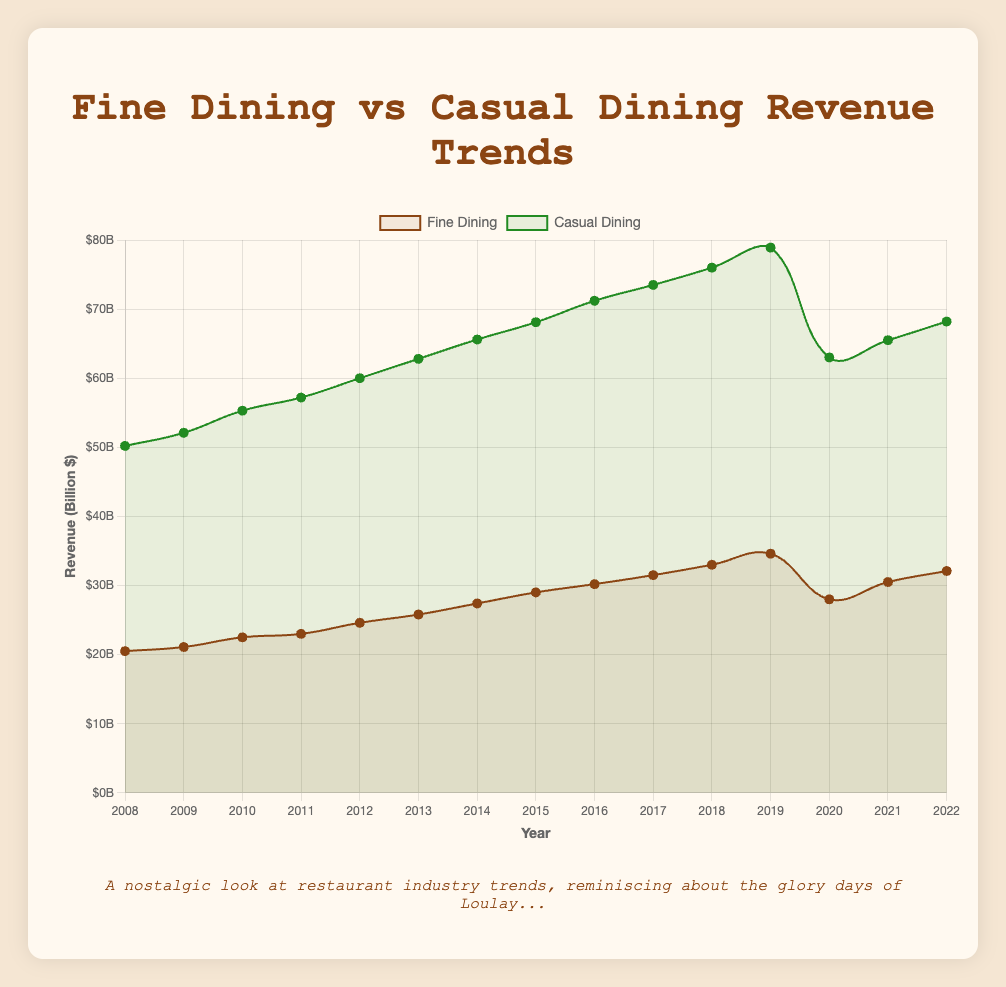What is the revenue difference between fine dining and casual dining in 2015? In 2015, fine dining revenue was $29.0 billion and casual dining revenue was $68.1 billion. The difference is $68.1 billion - $29.0 billion.
Answer: $39.1 billion Which year had the highest revenue for casual dining? By examining the plot, the highest point on the casual dining line corresponds to the year 2019.
Answer: 2019 In which year did fine dining revenue see the largest increase compared to the previous year? The largest increase in fine dining revenue occurred between 2012 and 2013, where the revenue increased from $24.6 billion to $25.8 billion.
Answer: 2013 What was the percentage drop in fine dining revenue from 2019 to 2020? Fine dining revenue dropped from $34.6 billion in 2019 to $28.0 billion in 2020. The percentage drop is calculated as ((34.6 - 28.0) / 34.6) * 100.
Answer: 19.1% Which type of dining experienced a steeper decline in revenue during 2020? Both fine dining and casual dining shows a decline in 2020, but the visual drop is steeper for fine dining. Fine dining drops from $34.6 billion to $28.0 billion, while casual dining drops from $78.9 billion to $63.0 billion. Fine dining's drop is steeper.
Answer: Fine dining How did the revenues for fine dining and casual dining compare in 2021? In 2021, fine dining revenue was $30.5 billion and casual dining revenue was $65.5 billion. Casual dining had higher revenue.
Answer: Casual dining had higher revenue What's the average annual revenue of fine dining between 2008 and 2022? Sum the revenues from 2008 to 2022 (20.5 + 21.1 + 22.5 + 23.0 + 24.6 + 25.8 + 27.4 + 29.0 + 30.2 + 31.5 + 33.0 + 34.6 + 28.0 + 30.5 + 32.1) which is 413.8, then divide by 15 years. The average revenue is 413.8 / 15.
Answer: $27.6 billion By how much did the revenue for casual dining increase from 2008 to 2018? Casual dining revenue was $50.2 billion in 2008 and increased to $76.0 billion by 2018. The increase is 76.0 - 50.2.
Answer: $25.8 billion What was the trend of casual dining revenue from 2008 to 2022? Casual dining revenue generally increased from 2008 to 2019, with a peak in 2019, then saw a significant drop in 2020 due to likely external factors, followed by a gradual recovery up to 2022.
Answer: Increasing with a peak in 2019, drop in 2020, then recovery If the trend from 2014 to 2019 continued uninterrupted, what would you predict the 2020 revenue for fine dining to be? The average annual increase from 2014 to 2019 in fine dining revenue can be found by averaging the yearly increments (27.4 -> 29.0 -> 30.2 -> 31.5 -> 33.0 -> 34.6). Once calculated, add this average to the 2019 revenue to project 2020. The increments are (1.6 + 1.2 + 1.3 + 1.5 + 1.6) sum to 7.2/5 = 1.44 billion; adding this to 34.6 gives the projection.
Answer: $36.04 billion 